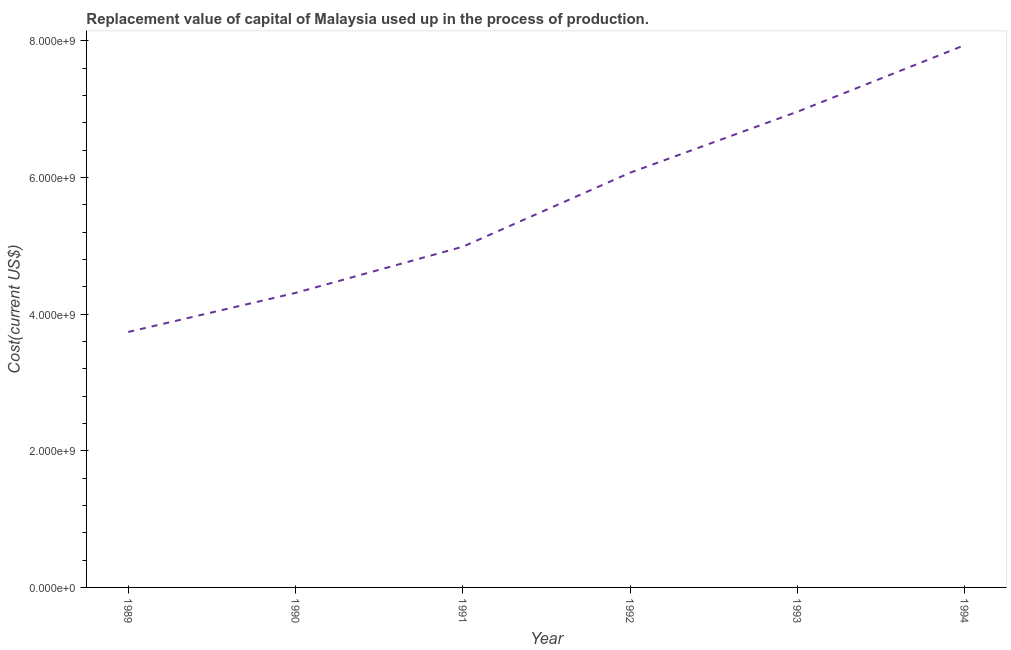What is the consumption of fixed capital in 1992?
Provide a short and direct response. 6.07e+09. Across all years, what is the maximum consumption of fixed capital?
Make the answer very short. 7.94e+09. Across all years, what is the minimum consumption of fixed capital?
Offer a terse response. 3.74e+09. In which year was the consumption of fixed capital minimum?
Your answer should be compact. 1989. What is the sum of the consumption of fixed capital?
Offer a very short reply. 3.40e+1. What is the difference between the consumption of fixed capital in 1991 and 1992?
Offer a terse response. -1.08e+09. What is the average consumption of fixed capital per year?
Ensure brevity in your answer.  5.67e+09. What is the median consumption of fixed capital?
Provide a short and direct response. 5.53e+09. In how many years, is the consumption of fixed capital greater than 3200000000 US$?
Your answer should be very brief. 6. Do a majority of the years between 1994 and 1992 (inclusive) have consumption of fixed capital greater than 2800000000 US$?
Your response must be concise. No. What is the ratio of the consumption of fixed capital in 1993 to that in 1994?
Make the answer very short. 0.88. Is the difference between the consumption of fixed capital in 1991 and 1994 greater than the difference between any two years?
Offer a very short reply. No. What is the difference between the highest and the second highest consumption of fixed capital?
Offer a terse response. 9.75e+08. What is the difference between the highest and the lowest consumption of fixed capital?
Ensure brevity in your answer.  4.20e+09. Does the consumption of fixed capital monotonically increase over the years?
Give a very brief answer. Yes. Are the values on the major ticks of Y-axis written in scientific E-notation?
Offer a terse response. Yes. Does the graph contain grids?
Your response must be concise. No. What is the title of the graph?
Make the answer very short. Replacement value of capital of Malaysia used up in the process of production. What is the label or title of the X-axis?
Provide a short and direct response. Year. What is the label or title of the Y-axis?
Your response must be concise. Cost(current US$). What is the Cost(current US$) in 1989?
Your answer should be compact. 3.74e+09. What is the Cost(current US$) of 1990?
Offer a very short reply. 4.31e+09. What is the Cost(current US$) of 1991?
Provide a succinct answer. 4.99e+09. What is the Cost(current US$) of 1992?
Your answer should be very brief. 6.07e+09. What is the Cost(current US$) in 1993?
Make the answer very short. 6.96e+09. What is the Cost(current US$) in 1994?
Your answer should be very brief. 7.94e+09. What is the difference between the Cost(current US$) in 1989 and 1990?
Ensure brevity in your answer.  -5.72e+08. What is the difference between the Cost(current US$) in 1989 and 1991?
Your answer should be very brief. -1.25e+09. What is the difference between the Cost(current US$) in 1989 and 1992?
Ensure brevity in your answer.  -2.33e+09. What is the difference between the Cost(current US$) in 1989 and 1993?
Offer a very short reply. -3.22e+09. What is the difference between the Cost(current US$) in 1989 and 1994?
Give a very brief answer. -4.20e+09. What is the difference between the Cost(current US$) in 1990 and 1991?
Your answer should be very brief. -6.76e+08. What is the difference between the Cost(current US$) in 1990 and 1992?
Your answer should be compact. -1.76e+09. What is the difference between the Cost(current US$) in 1990 and 1993?
Make the answer very short. -2.65e+09. What is the difference between the Cost(current US$) in 1990 and 1994?
Make the answer very short. -3.63e+09. What is the difference between the Cost(current US$) in 1991 and 1992?
Make the answer very short. -1.08e+09. What is the difference between the Cost(current US$) in 1991 and 1993?
Provide a short and direct response. -1.98e+09. What is the difference between the Cost(current US$) in 1991 and 1994?
Your answer should be very brief. -2.95e+09. What is the difference between the Cost(current US$) in 1992 and 1993?
Your answer should be compact. -8.92e+08. What is the difference between the Cost(current US$) in 1992 and 1994?
Offer a very short reply. -1.87e+09. What is the difference between the Cost(current US$) in 1993 and 1994?
Offer a very short reply. -9.75e+08. What is the ratio of the Cost(current US$) in 1989 to that in 1990?
Make the answer very short. 0.87. What is the ratio of the Cost(current US$) in 1989 to that in 1991?
Your answer should be compact. 0.75. What is the ratio of the Cost(current US$) in 1989 to that in 1992?
Give a very brief answer. 0.62. What is the ratio of the Cost(current US$) in 1989 to that in 1993?
Provide a short and direct response. 0.54. What is the ratio of the Cost(current US$) in 1989 to that in 1994?
Provide a succinct answer. 0.47. What is the ratio of the Cost(current US$) in 1990 to that in 1991?
Your response must be concise. 0.86. What is the ratio of the Cost(current US$) in 1990 to that in 1992?
Ensure brevity in your answer.  0.71. What is the ratio of the Cost(current US$) in 1990 to that in 1993?
Offer a very short reply. 0.62. What is the ratio of the Cost(current US$) in 1990 to that in 1994?
Your response must be concise. 0.54. What is the ratio of the Cost(current US$) in 1991 to that in 1992?
Ensure brevity in your answer.  0.82. What is the ratio of the Cost(current US$) in 1991 to that in 1993?
Your answer should be very brief. 0.72. What is the ratio of the Cost(current US$) in 1991 to that in 1994?
Your answer should be compact. 0.63. What is the ratio of the Cost(current US$) in 1992 to that in 1993?
Your answer should be compact. 0.87. What is the ratio of the Cost(current US$) in 1992 to that in 1994?
Offer a very short reply. 0.77. What is the ratio of the Cost(current US$) in 1993 to that in 1994?
Offer a terse response. 0.88. 